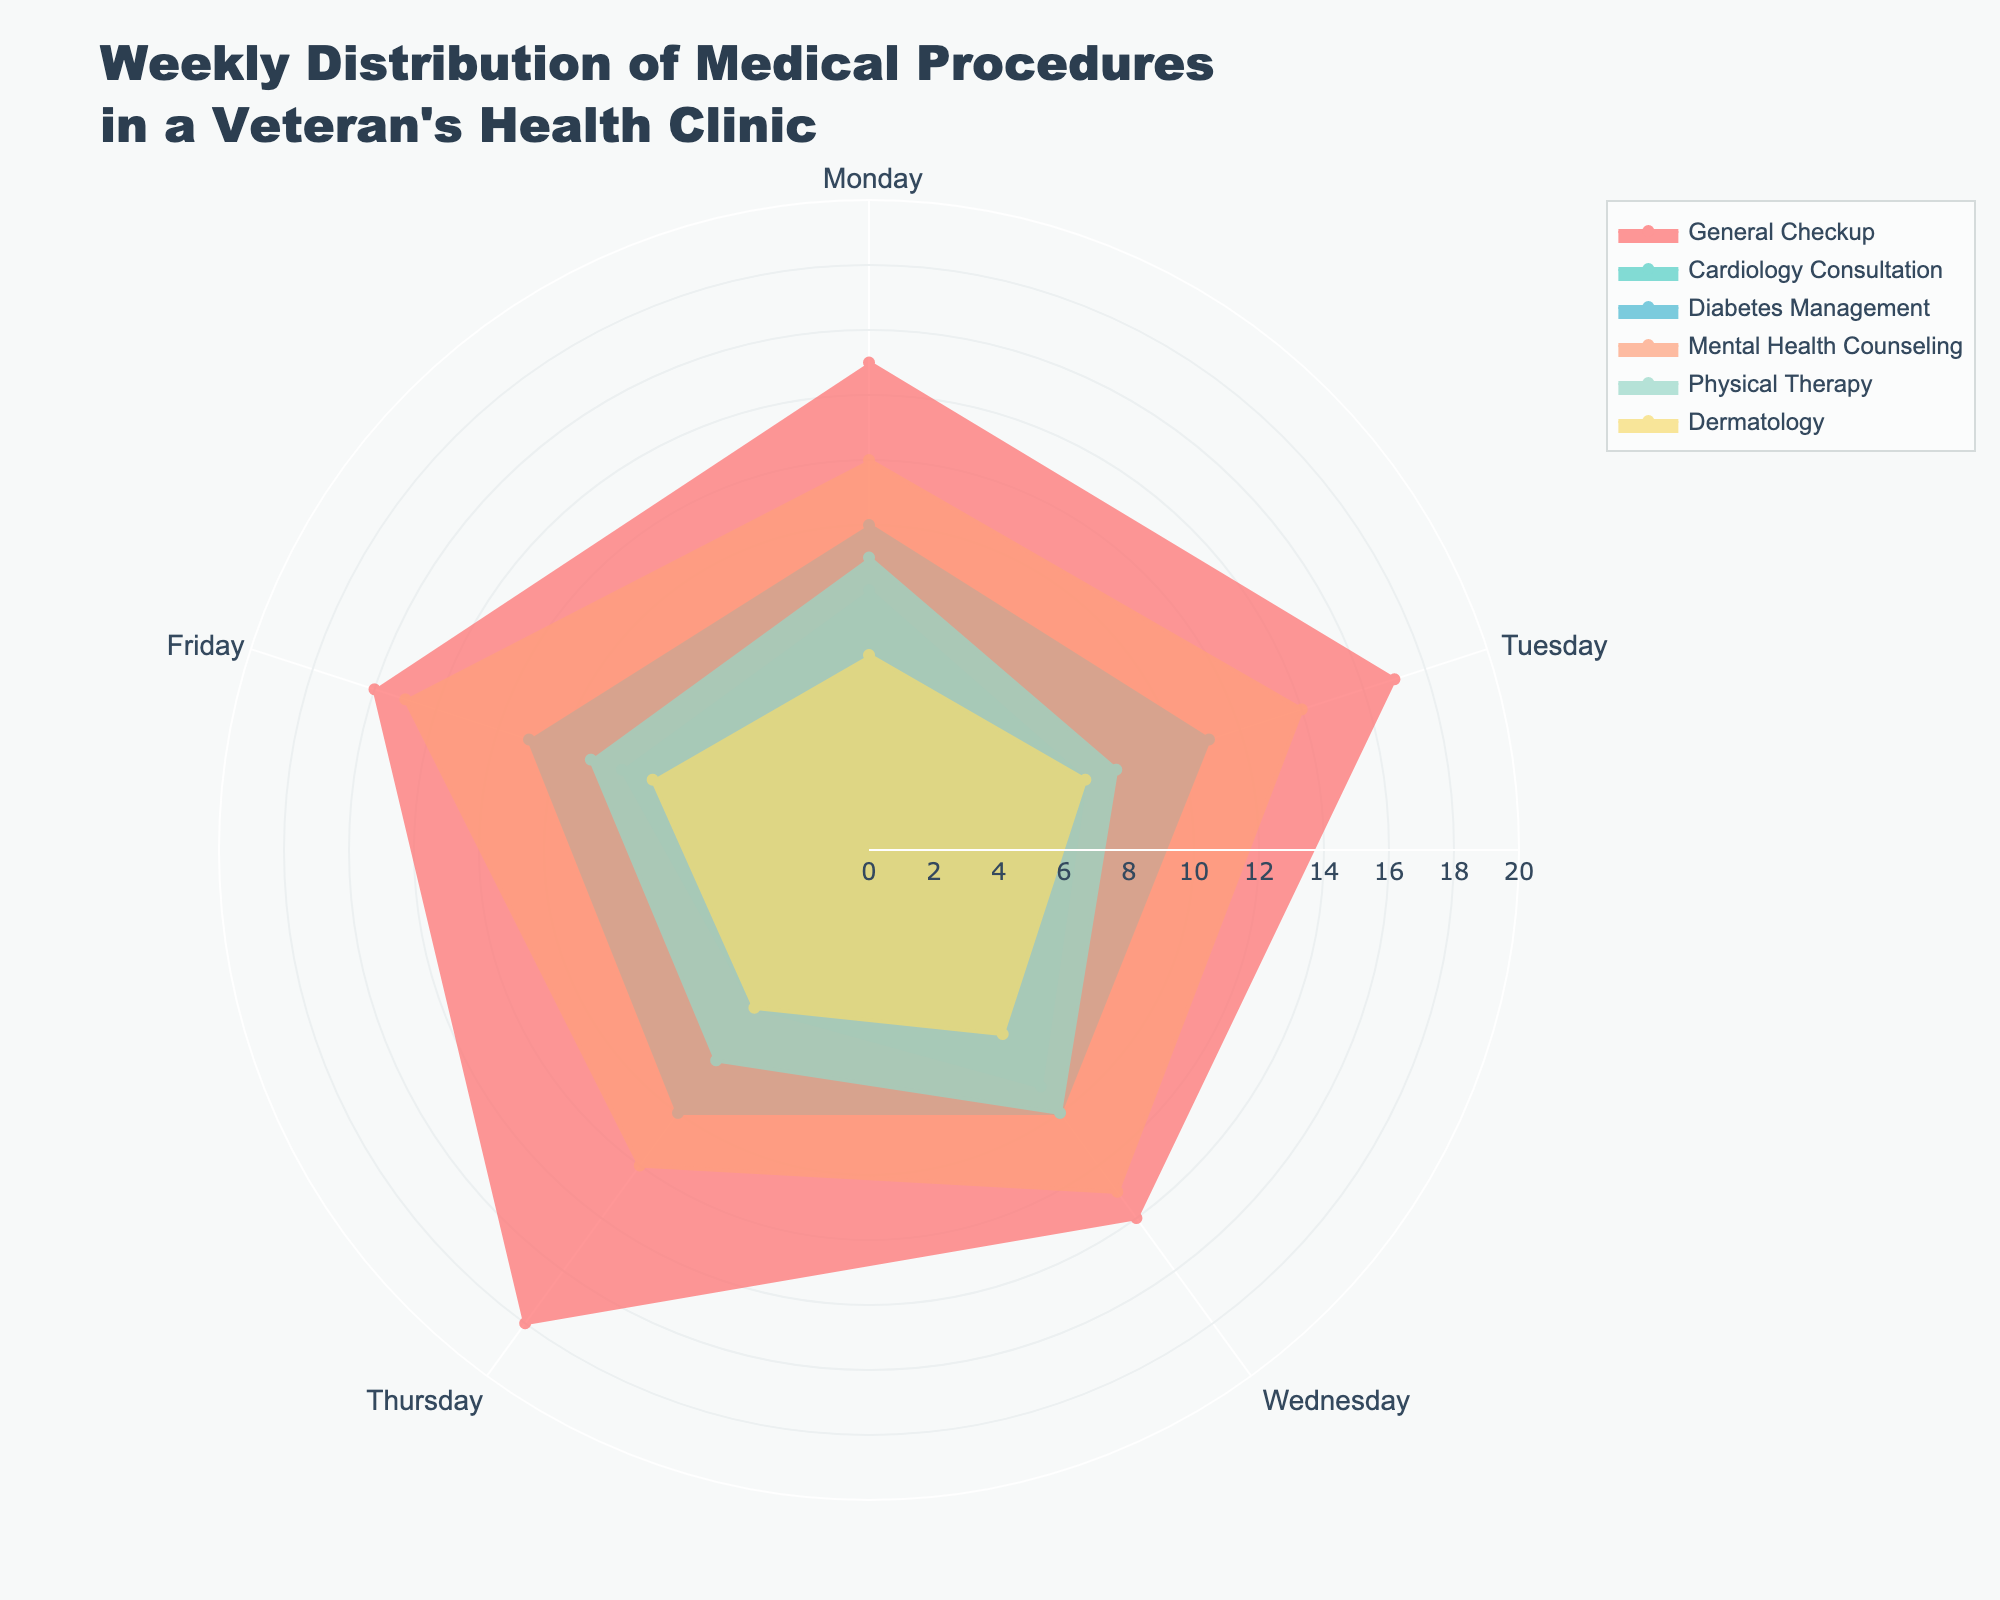What is the title of the chart? The title of the chart appears at the top and states, "Weekly Distribution of Medical Procedures in a Veteran's Health Clinic."
Answer: Weekly Distribution of Medical Procedures in a Veteran's Health Clinic What type of procedure is conducted most frequently on Wednesdays? By examining the lengths of the petals corresponding to Wednesday, the "General Checkup" petal is the longest, indicating it is the most frequently conducted procedure.
Answer: General Checkup How many procedures are conducted on average on Fridays for General Checkups and Physical Therapy? First, note the number of procedures on Fridays for both General Checkups (16) and Physical Therapy (9). Add these values and divide by 2 to get the average: (16 + 9) / 2 = 12.5.
Answer: 12.5 Which procedure shows the most consistent number of occurrences across the week? By looking at the lengths of the petals for each procedure across all days, "Diabetes Management" has similar length petals for all days, indicating the most consistent occurrences.
Answer: Diabetes Management On what day is Dermatology conducted the most frequently? By comparing the lengths of the petals for Dermatology across all days, the Tuesday petal is the longest, indicating the highest frequency.
Answer: Tuesday How many procedures are conducted in total for Mental Health Counseling throughout the week? Sum the numbers for Mental Health Counseling for all days: 12 (Monday) + 14 (Tuesday) + 13 (Wednesday) + 12 (Thursday) + 15 (Friday) = 66.
Answer: 66 Which type of medical procedure has the highest average number of occurrences per day? To find this, calculate the average for each procedure across all days and compare: 
- General Checkup: (15+17+14+18+16)/5 = 16
- Cardiology Consultation: (8+7+9+6+8)/5 = 7.6
- Diabetes Management: (10+11+10+10+11)/5 = 10.4
- Mental Health Counseling: (12+14+13+12+15)/5 = 13.2
- Physical Therapy: (9+8+10+8+9)/5 = 8.8
- Dermatology: (6+7+7+6+7)/5 = 6.6
Thus, General Checkup has the highest average.
Answer: General Checkup Which procedure shows the greatest variation in occurrences throughout the week? By examining the range (difference between the maximum and minimum) for each procedure:
- General Checkup: 18 - 14 = 4
- Cardiology Consultation: 9 - 6 = 3
- Diabetes Management: 11 - 10 = 1
- Mental Health Counseling: 15 - 12 = 3
- Physical Therapy: 10 - 8 = 2
- Dermatology: 7 - 6 = 1
General Checkup has the greatest variation.
Answer: General Checkup Is the number of Cardiology Consultations on Monday greater than the number of Physical Therapy sessions on Wednesday? Compare the values for Cardiology Consultation on Monday (8) with Physical Therapy on Wednesday (10); 8 is less than 10.
Answer: No Which day has the highest combined number of General Checkups and Diabetes Management procedures? Calculate the combined occurrences for each day:
- Monday: 15 + 10 = 25
- Tuesday: 17 + 11 = 28
- Wednesday: 14 + 10 = 24
- Thursday: 18 + 10 = 28
- Friday: 16 + 11 = 27
Tuesday and Thursday both have the highest combined number (28).
Answer: Tuesday and Thursday 